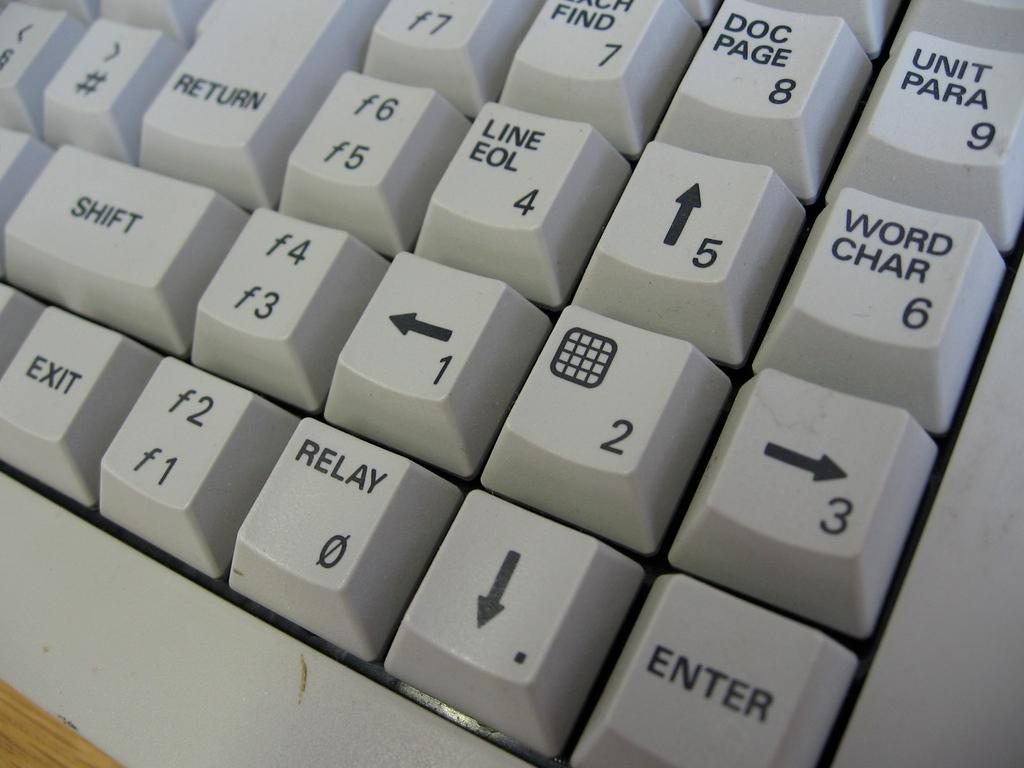<image>
Write a terse but informative summary of the picture. a close up of a keyboard with keys Line/EOL and Doc/Page 